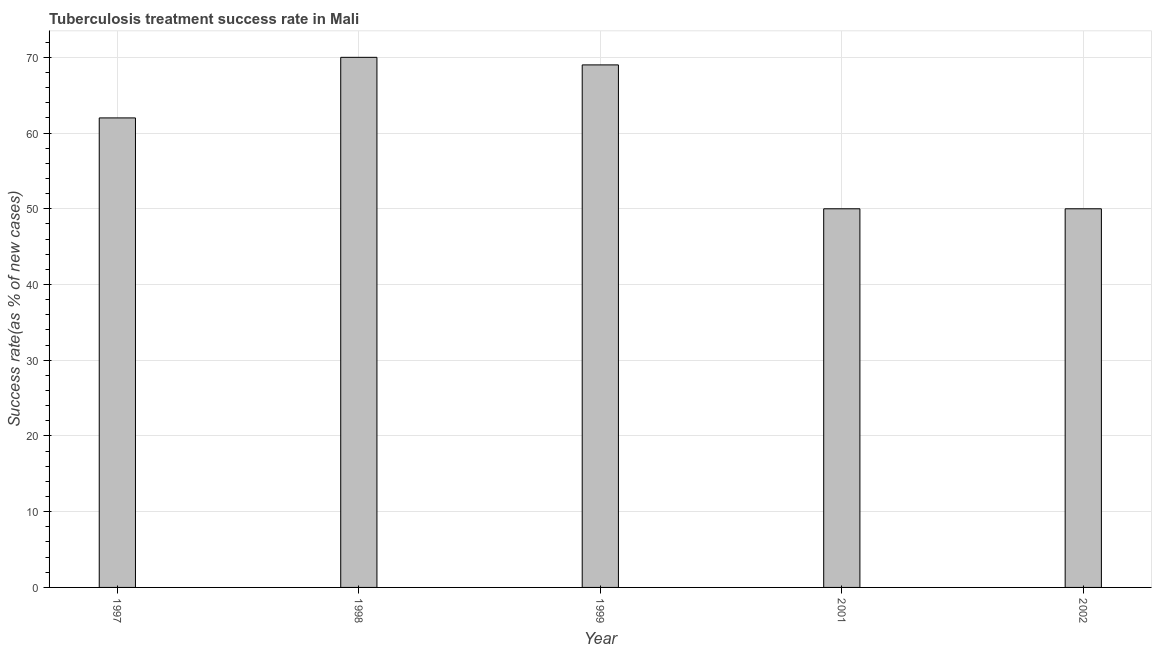Does the graph contain any zero values?
Provide a short and direct response. No. What is the title of the graph?
Offer a terse response. Tuberculosis treatment success rate in Mali. What is the label or title of the X-axis?
Provide a short and direct response. Year. What is the label or title of the Y-axis?
Your answer should be very brief. Success rate(as % of new cases). What is the tuberculosis treatment success rate in 1999?
Offer a terse response. 69. Across all years, what is the maximum tuberculosis treatment success rate?
Your answer should be compact. 70. Across all years, what is the minimum tuberculosis treatment success rate?
Your response must be concise. 50. In which year was the tuberculosis treatment success rate minimum?
Offer a very short reply. 2001. What is the sum of the tuberculosis treatment success rate?
Provide a succinct answer. 301. In how many years, is the tuberculosis treatment success rate greater than 50 %?
Make the answer very short. 3. Do a majority of the years between 1998 and 1997 (inclusive) have tuberculosis treatment success rate greater than 32 %?
Your answer should be compact. No. Is the tuberculosis treatment success rate in 1998 less than that in 2001?
Provide a short and direct response. No. Is the difference between the tuberculosis treatment success rate in 1999 and 2002 greater than the difference between any two years?
Your response must be concise. No. What is the difference between the highest and the second highest tuberculosis treatment success rate?
Your response must be concise. 1. Is the sum of the tuberculosis treatment success rate in 1998 and 1999 greater than the maximum tuberculosis treatment success rate across all years?
Give a very brief answer. Yes. What is the difference between the highest and the lowest tuberculosis treatment success rate?
Give a very brief answer. 20. Are all the bars in the graph horizontal?
Your answer should be compact. No. How many years are there in the graph?
Offer a very short reply. 5. What is the difference between two consecutive major ticks on the Y-axis?
Offer a terse response. 10. What is the Success rate(as % of new cases) of 1998?
Your response must be concise. 70. What is the difference between the Success rate(as % of new cases) in 1997 and 1998?
Give a very brief answer. -8. What is the difference between the Success rate(as % of new cases) in 1997 and 2001?
Make the answer very short. 12. What is the difference between the Success rate(as % of new cases) in 1998 and 1999?
Your answer should be compact. 1. What is the difference between the Success rate(as % of new cases) in 2001 and 2002?
Offer a terse response. 0. What is the ratio of the Success rate(as % of new cases) in 1997 to that in 1998?
Your answer should be compact. 0.89. What is the ratio of the Success rate(as % of new cases) in 1997 to that in 1999?
Give a very brief answer. 0.9. What is the ratio of the Success rate(as % of new cases) in 1997 to that in 2001?
Offer a very short reply. 1.24. What is the ratio of the Success rate(as % of new cases) in 1997 to that in 2002?
Give a very brief answer. 1.24. What is the ratio of the Success rate(as % of new cases) in 1998 to that in 1999?
Your answer should be compact. 1.01. What is the ratio of the Success rate(as % of new cases) in 1998 to that in 2002?
Provide a short and direct response. 1.4. What is the ratio of the Success rate(as % of new cases) in 1999 to that in 2001?
Make the answer very short. 1.38. What is the ratio of the Success rate(as % of new cases) in 1999 to that in 2002?
Your answer should be very brief. 1.38. 